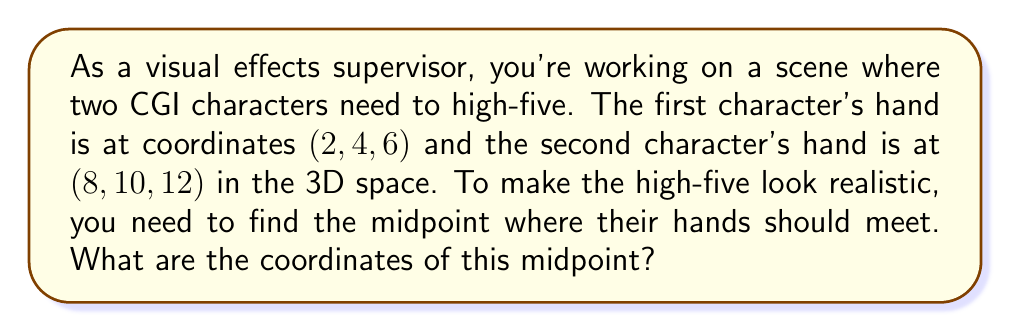Solve this math problem. To find the midpoint between two points in 3D space, we need to calculate the average of each coordinate. Let's break it down step-by-step:

1. Identify the coordinates:
   Point 1: $(x_1, y_1, z_1) = (2, 4, 6)$
   Point 2: $(x_2, y_2, z_2) = (8, 10, 12)$

2. The midpoint formula for 3D coordinates is:
   $$(x_m, y_m, z_m) = (\frac{x_1 + x_2}{2}, \frac{y_1 + y_2}{2}, \frac{z_1 + z_2}{2})$$

3. Calculate each coordinate of the midpoint:
   
   $x_m = \frac{x_1 + x_2}{2} = \frac{2 + 8}{2} = \frac{10}{2} = 5$
   
   $y_m = \frac{y_1 + y_2}{2} = \frac{4 + 10}{2} = \frac{14}{2} = 7$
   
   $z_m = \frac{z_1 + z_2}{2} = \frac{6 + 12}{2} = \frac{18}{2} = 9$

4. Combine the results to get the midpoint coordinates.
Answer: The midpoint coordinates are $(5, 7, 9)$. 